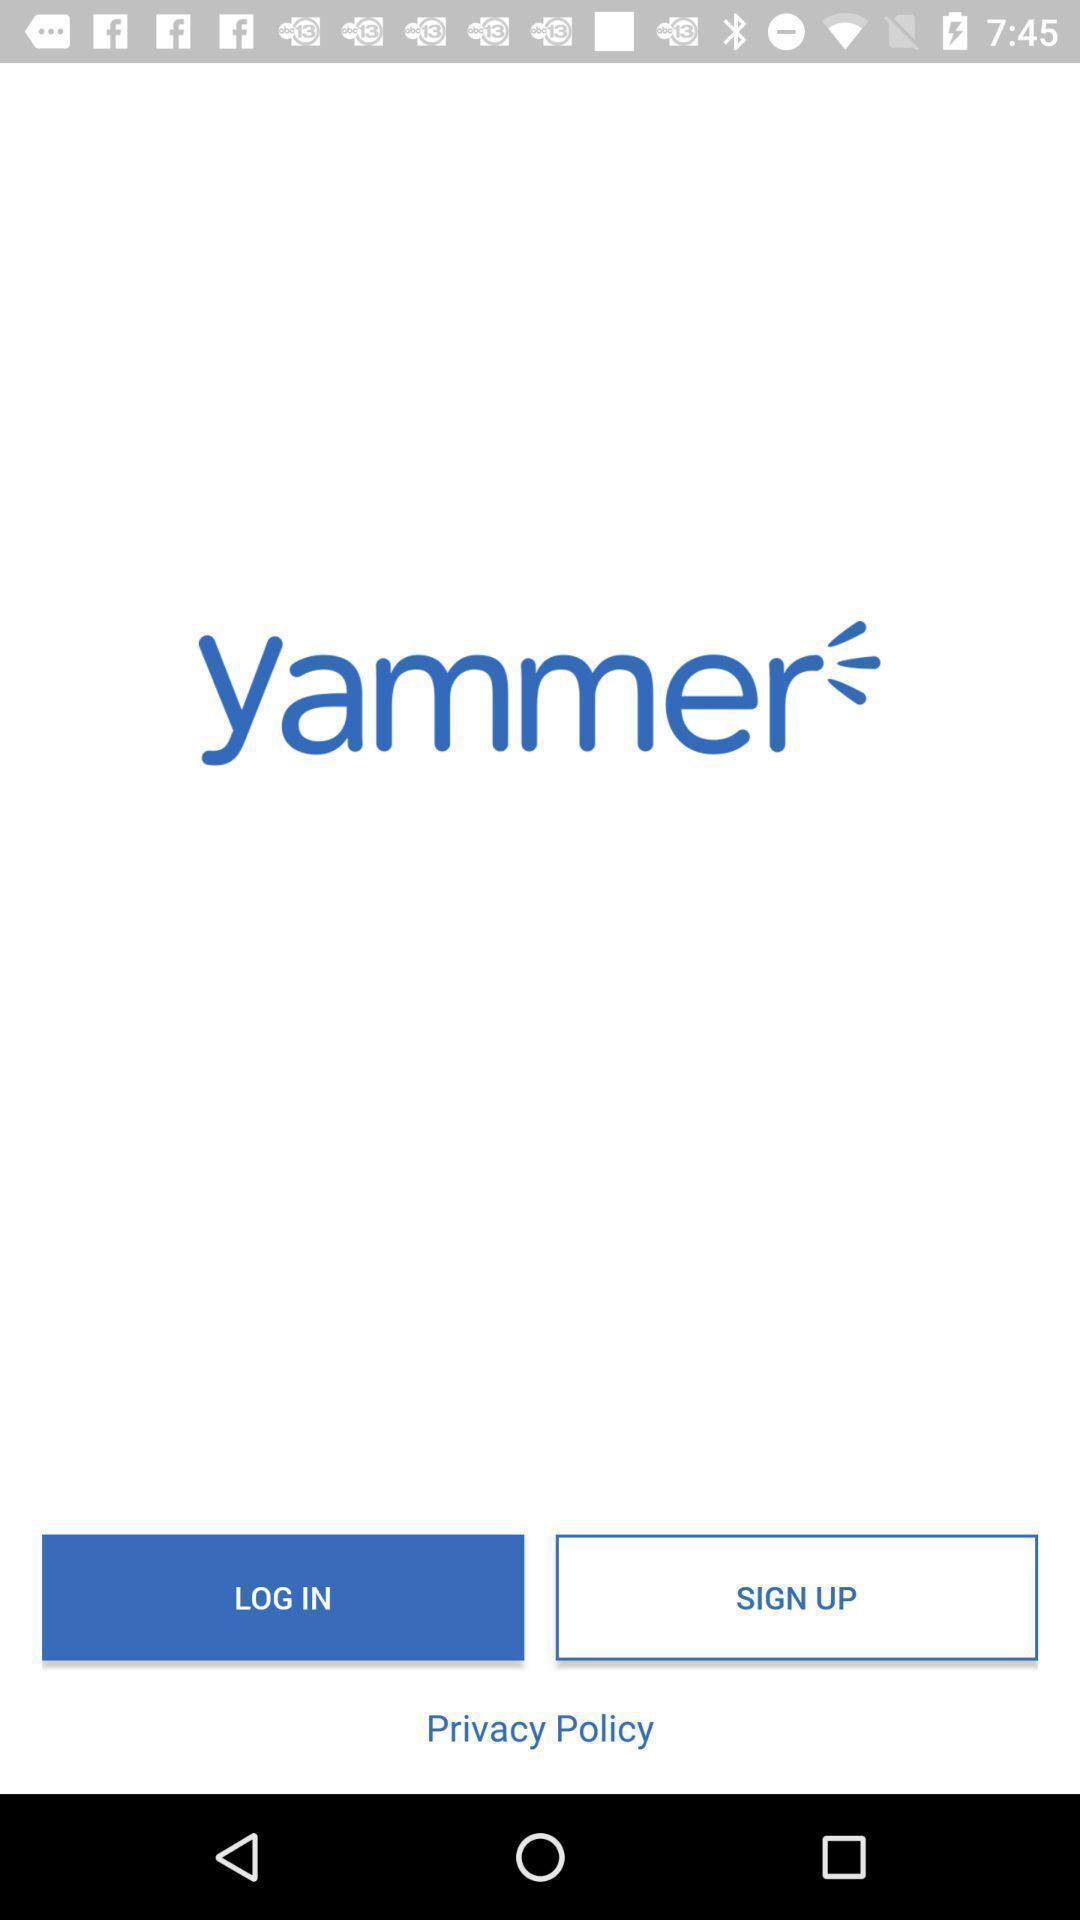Explain the elements present in this screenshot. Welcome page. 